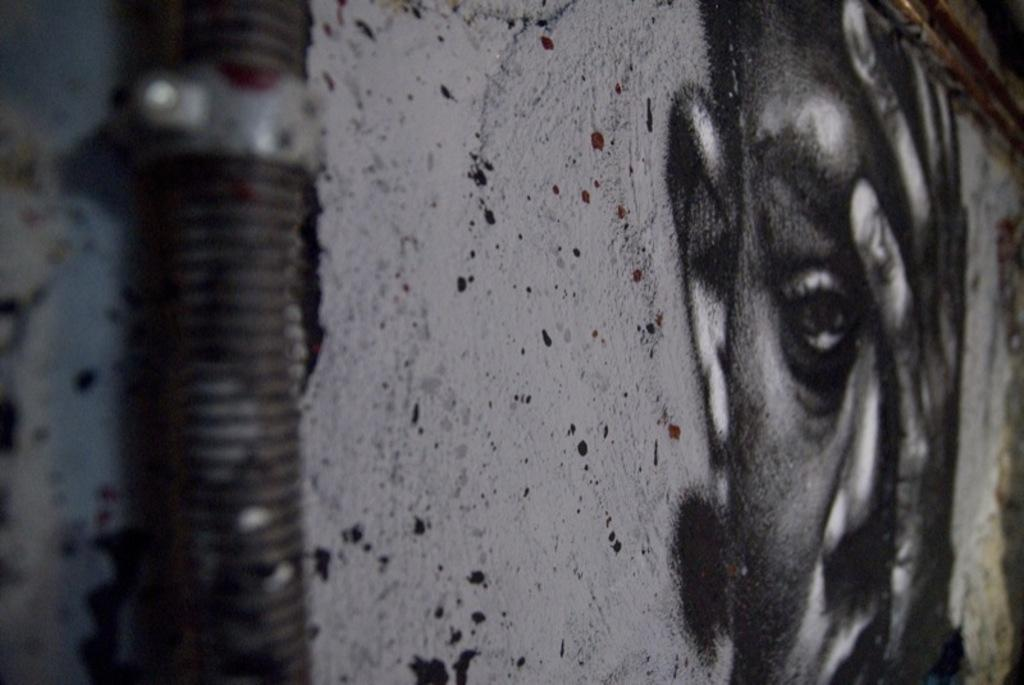What is depicted on the wall in the image? There is a painting of a man's face on the wall. What else can be seen on the wall in the image? There is a pipe fixed to the wall. What theory is being proposed by the man's face in the painting? The painting is not proposing a theory; it is a depiction of a man's face. How does the pipe contribute to the digestion process in the image? The image does not show any digestion process, and the pipe is simply fixed to the wall. 